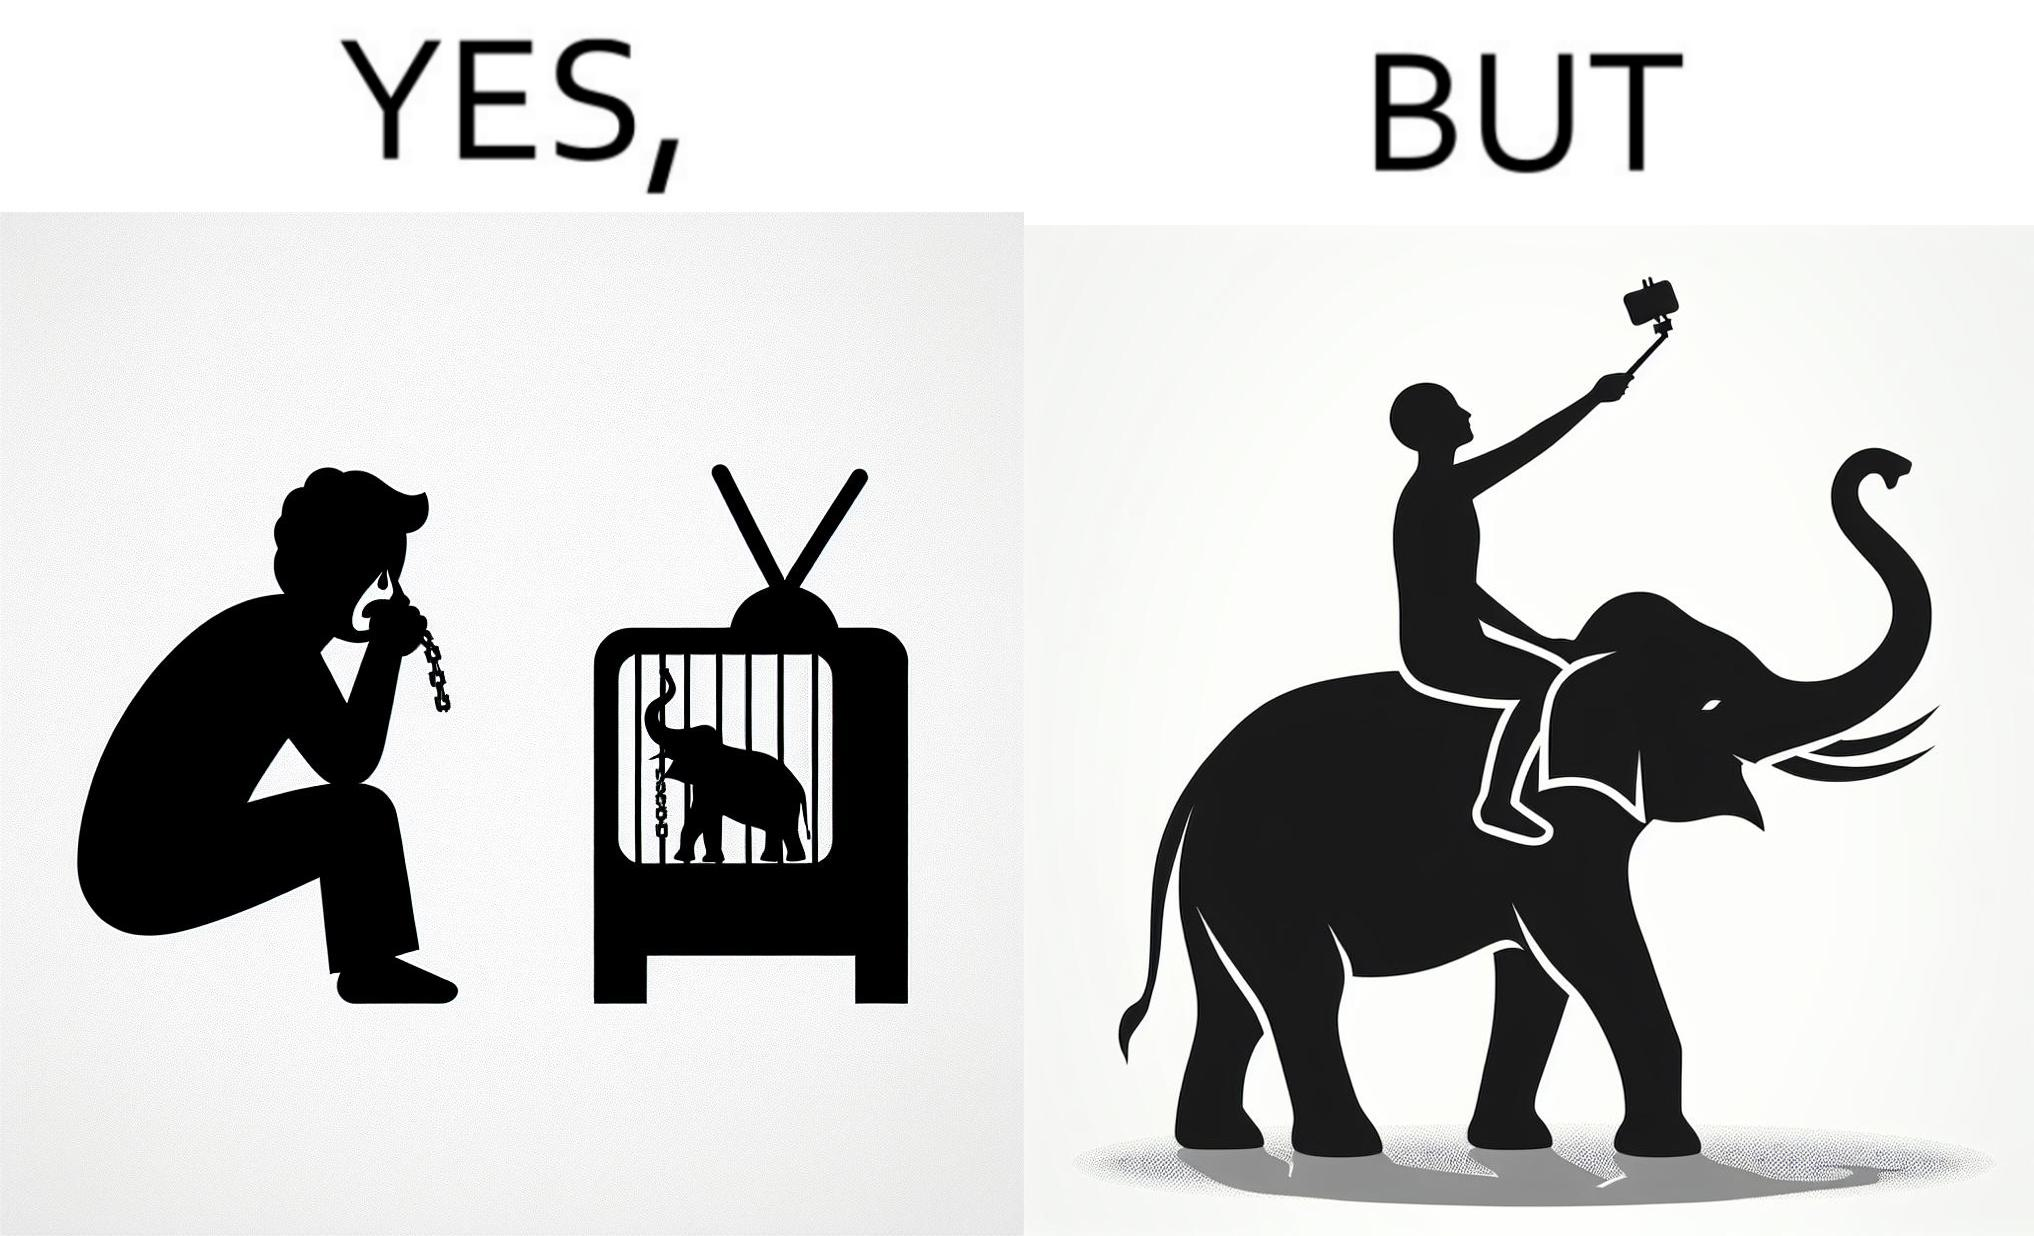Is there satirical content in this image? Yes, this image is satirical. 